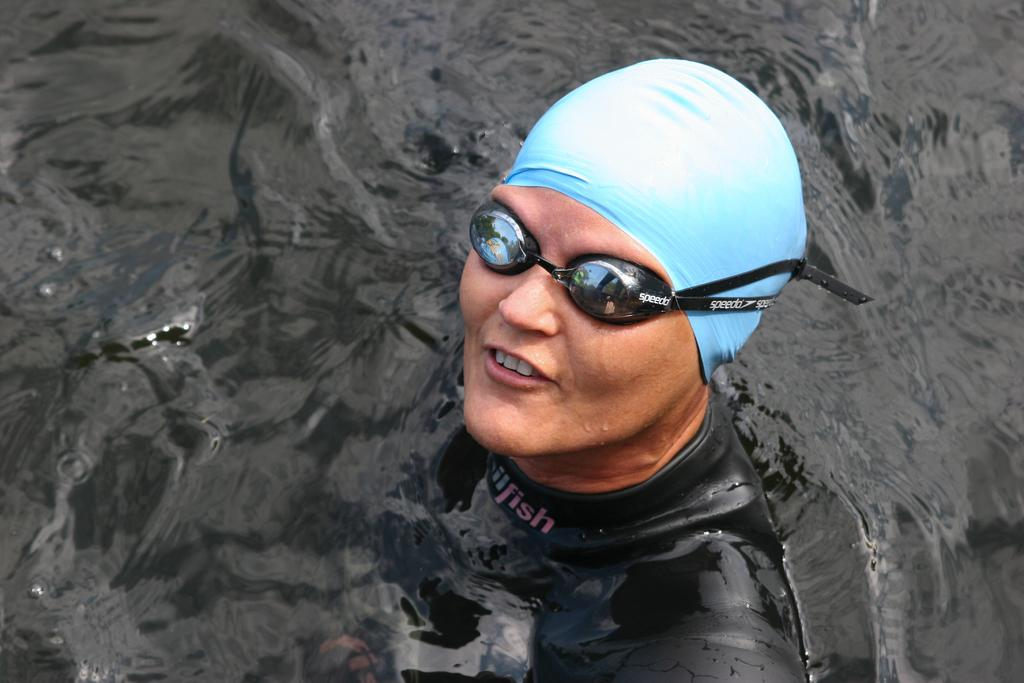What is the main subject of the image? There is a person in the image. What type of headwear is the person wearing? The person is wearing a cap. What type of eyewear is the person wearing? The person is wearing goggles. What is the person's location in the image? The person is in the water. What type of spoon is the person using to stir the water in the image? There is no spoon present in the image. How many children are visible in the image? There are no children present in the image. 